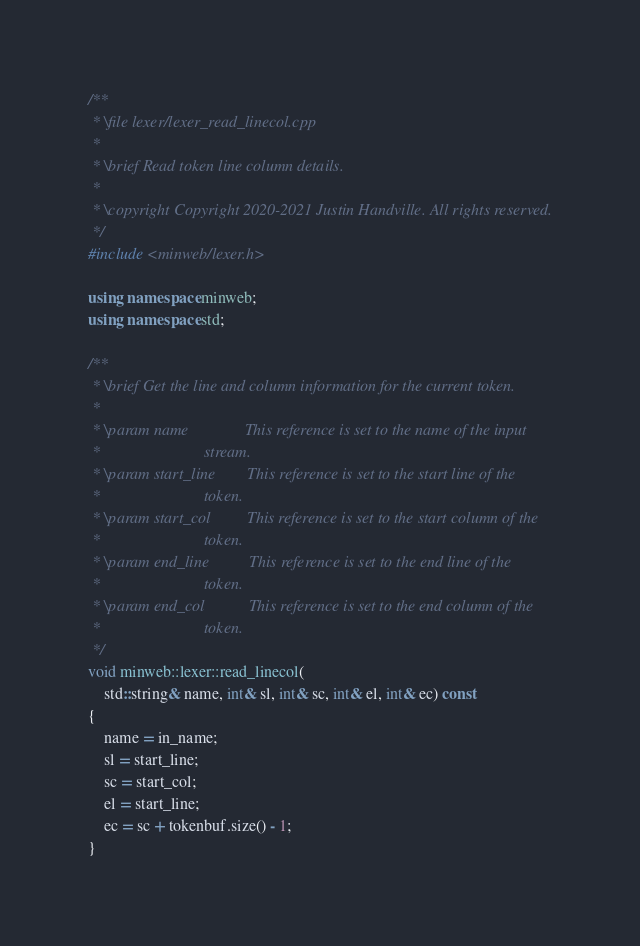<code> <loc_0><loc_0><loc_500><loc_500><_C++_>/**
 * \file lexer/lexer_read_linecol.cpp
 *
 * \brief Read token line column details.
 *
 * \copyright Copyright 2020-2021 Justin Handville. All rights reserved.
 */
#include <minweb/lexer.h>

using namespace minweb;
using namespace std;

/**
 * \brief Get the line and column information for the current token.
 *
 * \param name              This reference is set to the name of the input
 *                          stream.
 * \param start_line        This reference is set to the start line of the
 *                          token.
 * \param start_col         This reference is set to the start column of the
 *                          token.
 * \param end_line          This reference is set to the end line of the
 *                          token.
 * \param end_col           This reference is set to the end column of the
 *                          token.
 */
void minweb::lexer::read_linecol(
    std::string& name, int& sl, int& sc, int& el, int& ec) const
{
    name = in_name;
    sl = start_line;
    sc = start_col;
    el = start_line;
    ec = sc + tokenbuf.size() - 1;
}
</code> 